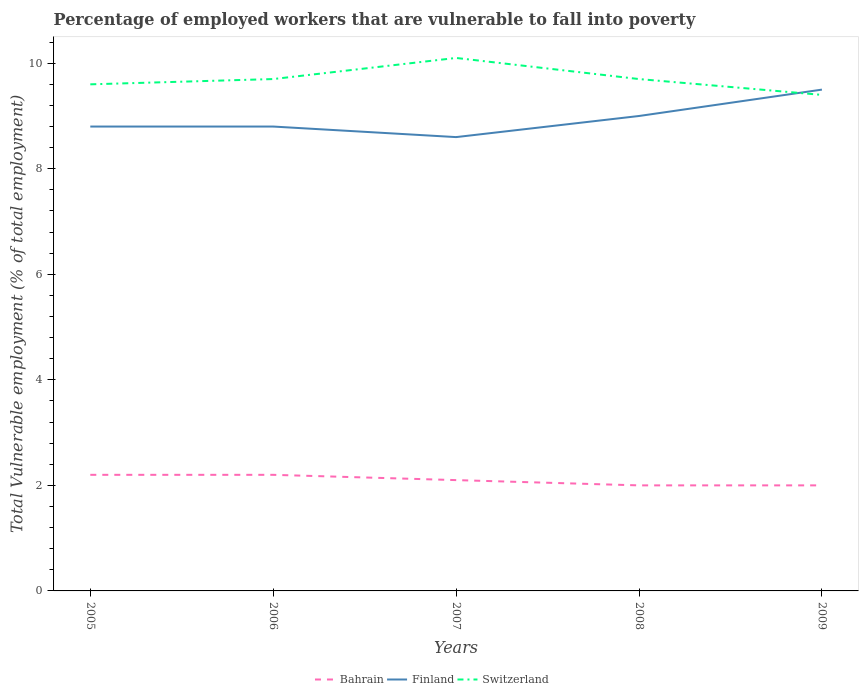Does the line corresponding to Bahrain intersect with the line corresponding to Finland?
Your response must be concise. No. What is the total percentage of employed workers who are vulnerable to fall into poverty in Finland in the graph?
Ensure brevity in your answer.  0. What is the difference between the highest and the second highest percentage of employed workers who are vulnerable to fall into poverty in Finland?
Make the answer very short. 0.9. What is the difference between the highest and the lowest percentage of employed workers who are vulnerable to fall into poverty in Switzerland?
Your answer should be compact. 1. What is the difference between two consecutive major ticks on the Y-axis?
Offer a very short reply. 2. Where does the legend appear in the graph?
Make the answer very short. Bottom center. How are the legend labels stacked?
Keep it short and to the point. Horizontal. What is the title of the graph?
Make the answer very short. Percentage of employed workers that are vulnerable to fall into poverty. What is the label or title of the Y-axis?
Provide a succinct answer. Total Vulnerable employment (% of total employment). What is the Total Vulnerable employment (% of total employment) of Bahrain in 2005?
Provide a short and direct response. 2.2. What is the Total Vulnerable employment (% of total employment) in Finland in 2005?
Your answer should be very brief. 8.8. What is the Total Vulnerable employment (% of total employment) of Switzerland in 2005?
Your answer should be compact. 9.6. What is the Total Vulnerable employment (% of total employment) of Bahrain in 2006?
Make the answer very short. 2.2. What is the Total Vulnerable employment (% of total employment) in Finland in 2006?
Offer a terse response. 8.8. What is the Total Vulnerable employment (% of total employment) in Switzerland in 2006?
Offer a terse response. 9.7. What is the Total Vulnerable employment (% of total employment) of Bahrain in 2007?
Offer a terse response. 2.1. What is the Total Vulnerable employment (% of total employment) in Finland in 2007?
Provide a short and direct response. 8.6. What is the Total Vulnerable employment (% of total employment) in Switzerland in 2007?
Offer a very short reply. 10.1. What is the Total Vulnerable employment (% of total employment) of Switzerland in 2008?
Your response must be concise. 9.7. What is the Total Vulnerable employment (% of total employment) of Bahrain in 2009?
Make the answer very short. 2. What is the Total Vulnerable employment (% of total employment) in Finland in 2009?
Provide a succinct answer. 9.5. What is the Total Vulnerable employment (% of total employment) in Switzerland in 2009?
Give a very brief answer. 9.4. Across all years, what is the maximum Total Vulnerable employment (% of total employment) of Bahrain?
Make the answer very short. 2.2. Across all years, what is the maximum Total Vulnerable employment (% of total employment) in Switzerland?
Ensure brevity in your answer.  10.1. Across all years, what is the minimum Total Vulnerable employment (% of total employment) in Bahrain?
Your answer should be very brief. 2. Across all years, what is the minimum Total Vulnerable employment (% of total employment) in Finland?
Keep it short and to the point. 8.6. Across all years, what is the minimum Total Vulnerable employment (% of total employment) of Switzerland?
Provide a succinct answer. 9.4. What is the total Total Vulnerable employment (% of total employment) of Bahrain in the graph?
Your answer should be very brief. 10.5. What is the total Total Vulnerable employment (% of total employment) of Finland in the graph?
Offer a terse response. 44.7. What is the total Total Vulnerable employment (% of total employment) of Switzerland in the graph?
Provide a succinct answer. 48.5. What is the difference between the Total Vulnerable employment (% of total employment) in Finland in 2005 and that in 2006?
Your answer should be very brief. 0. What is the difference between the Total Vulnerable employment (% of total employment) of Finland in 2005 and that in 2007?
Your response must be concise. 0.2. What is the difference between the Total Vulnerable employment (% of total employment) in Finland in 2005 and that in 2008?
Your answer should be compact. -0.2. What is the difference between the Total Vulnerable employment (% of total employment) of Switzerland in 2005 and that in 2008?
Your answer should be compact. -0.1. What is the difference between the Total Vulnerable employment (% of total employment) of Switzerland in 2005 and that in 2009?
Your response must be concise. 0.2. What is the difference between the Total Vulnerable employment (% of total employment) of Bahrain in 2006 and that in 2008?
Give a very brief answer. 0.2. What is the difference between the Total Vulnerable employment (% of total employment) in Switzerland in 2006 and that in 2008?
Offer a very short reply. 0. What is the difference between the Total Vulnerable employment (% of total employment) of Finland in 2006 and that in 2009?
Give a very brief answer. -0.7. What is the difference between the Total Vulnerable employment (% of total employment) of Bahrain in 2007 and that in 2008?
Provide a succinct answer. 0.1. What is the difference between the Total Vulnerable employment (% of total employment) in Finland in 2007 and that in 2009?
Your answer should be very brief. -0.9. What is the difference between the Total Vulnerable employment (% of total employment) in Finland in 2008 and that in 2009?
Your answer should be compact. -0.5. What is the difference between the Total Vulnerable employment (% of total employment) in Finland in 2005 and the Total Vulnerable employment (% of total employment) in Switzerland in 2006?
Your answer should be very brief. -0.9. What is the difference between the Total Vulnerable employment (% of total employment) in Bahrain in 2005 and the Total Vulnerable employment (% of total employment) in Finland in 2007?
Keep it short and to the point. -6.4. What is the difference between the Total Vulnerable employment (% of total employment) in Bahrain in 2005 and the Total Vulnerable employment (% of total employment) in Switzerland in 2009?
Give a very brief answer. -7.2. What is the difference between the Total Vulnerable employment (% of total employment) in Bahrain in 2006 and the Total Vulnerable employment (% of total employment) in Finland in 2007?
Ensure brevity in your answer.  -6.4. What is the difference between the Total Vulnerable employment (% of total employment) in Finland in 2006 and the Total Vulnerable employment (% of total employment) in Switzerland in 2007?
Your answer should be very brief. -1.3. What is the difference between the Total Vulnerable employment (% of total employment) in Bahrain in 2006 and the Total Vulnerable employment (% of total employment) in Finland in 2008?
Keep it short and to the point. -6.8. What is the difference between the Total Vulnerable employment (% of total employment) in Finland in 2006 and the Total Vulnerable employment (% of total employment) in Switzerland in 2008?
Provide a succinct answer. -0.9. What is the difference between the Total Vulnerable employment (% of total employment) of Bahrain in 2006 and the Total Vulnerable employment (% of total employment) of Finland in 2009?
Keep it short and to the point. -7.3. What is the difference between the Total Vulnerable employment (% of total employment) in Bahrain in 2006 and the Total Vulnerable employment (% of total employment) in Switzerland in 2009?
Your response must be concise. -7.2. What is the difference between the Total Vulnerable employment (% of total employment) in Bahrain in 2007 and the Total Vulnerable employment (% of total employment) in Finland in 2008?
Offer a very short reply. -6.9. What is the difference between the Total Vulnerable employment (% of total employment) of Bahrain in 2007 and the Total Vulnerable employment (% of total employment) of Switzerland in 2008?
Make the answer very short. -7.6. What is the difference between the Total Vulnerable employment (% of total employment) in Finland in 2007 and the Total Vulnerable employment (% of total employment) in Switzerland in 2009?
Keep it short and to the point. -0.8. What is the difference between the Total Vulnerable employment (% of total employment) in Bahrain in 2008 and the Total Vulnerable employment (% of total employment) in Finland in 2009?
Give a very brief answer. -7.5. What is the difference between the Total Vulnerable employment (% of total employment) of Finland in 2008 and the Total Vulnerable employment (% of total employment) of Switzerland in 2009?
Make the answer very short. -0.4. What is the average Total Vulnerable employment (% of total employment) in Bahrain per year?
Provide a short and direct response. 2.1. What is the average Total Vulnerable employment (% of total employment) in Finland per year?
Keep it short and to the point. 8.94. What is the average Total Vulnerable employment (% of total employment) in Switzerland per year?
Your answer should be compact. 9.7. In the year 2005, what is the difference between the Total Vulnerable employment (% of total employment) in Bahrain and Total Vulnerable employment (% of total employment) in Finland?
Make the answer very short. -6.6. In the year 2005, what is the difference between the Total Vulnerable employment (% of total employment) of Finland and Total Vulnerable employment (% of total employment) of Switzerland?
Provide a succinct answer. -0.8. In the year 2006, what is the difference between the Total Vulnerable employment (% of total employment) in Bahrain and Total Vulnerable employment (% of total employment) in Switzerland?
Provide a succinct answer. -7.5. In the year 2006, what is the difference between the Total Vulnerable employment (% of total employment) in Finland and Total Vulnerable employment (% of total employment) in Switzerland?
Offer a very short reply. -0.9. In the year 2007, what is the difference between the Total Vulnerable employment (% of total employment) in Bahrain and Total Vulnerable employment (% of total employment) in Finland?
Your answer should be compact. -6.5. In the year 2007, what is the difference between the Total Vulnerable employment (% of total employment) of Bahrain and Total Vulnerable employment (% of total employment) of Switzerland?
Your response must be concise. -8. In the year 2008, what is the difference between the Total Vulnerable employment (% of total employment) of Bahrain and Total Vulnerable employment (% of total employment) of Finland?
Provide a short and direct response. -7. What is the ratio of the Total Vulnerable employment (% of total employment) in Bahrain in 2005 to that in 2006?
Your response must be concise. 1. What is the ratio of the Total Vulnerable employment (% of total employment) of Switzerland in 2005 to that in 2006?
Keep it short and to the point. 0.99. What is the ratio of the Total Vulnerable employment (% of total employment) in Bahrain in 2005 to that in 2007?
Provide a succinct answer. 1.05. What is the ratio of the Total Vulnerable employment (% of total employment) of Finland in 2005 to that in 2007?
Offer a terse response. 1.02. What is the ratio of the Total Vulnerable employment (% of total employment) of Switzerland in 2005 to that in 2007?
Provide a short and direct response. 0.95. What is the ratio of the Total Vulnerable employment (% of total employment) in Bahrain in 2005 to that in 2008?
Offer a terse response. 1.1. What is the ratio of the Total Vulnerable employment (% of total employment) in Finland in 2005 to that in 2008?
Give a very brief answer. 0.98. What is the ratio of the Total Vulnerable employment (% of total employment) of Bahrain in 2005 to that in 2009?
Offer a very short reply. 1.1. What is the ratio of the Total Vulnerable employment (% of total employment) of Finland in 2005 to that in 2009?
Provide a short and direct response. 0.93. What is the ratio of the Total Vulnerable employment (% of total employment) of Switzerland in 2005 to that in 2009?
Your answer should be compact. 1.02. What is the ratio of the Total Vulnerable employment (% of total employment) in Bahrain in 2006 to that in 2007?
Keep it short and to the point. 1.05. What is the ratio of the Total Vulnerable employment (% of total employment) of Finland in 2006 to that in 2007?
Your answer should be very brief. 1.02. What is the ratio of the Total Vulnerable employment (% of total employment) of Switzerland in 2006 to that in 2007?
Your answer should be very brief. 0.96. What is the ratio of the Total Vulnerable employment (% of total employment) in Finland in 2006 to that in 2008?
Make the answer very short. 0.98. What is the ratio of the Total Vulnerable employment (% of total employment) in Bahrain in 2006 to that in 2009?
Keep it short and to the point. 1.1. What is the ratio of the Total Vulnerable employment (% of total employment) in Finland in 2006 to that in 2009?
Offer a very short reply. 0.93. What is the ratio of the Total Vulnerable employment (% of total employment) in Switzerland in 2006 to that in 2009?
Offer a very short reply. 1.03. What is the ratio of the Total Vulnerable employment (% of total employment) of Finland in 2007 to that in 2008?
Provide a short and direct response. 0.96. What is the ratio of the Total Vulnerable employment (% of total employment) in Switzerland in 2007 to that in 2008?
Your answer should be very brief. 1.04. What is the ratio of the Total Vulnerable employment (% of total employment) of Bahrain in 2007 to that in 2009?
Your response must be concise. 1.05. What is the ratio of the Total Vulnerable employment (% of total employment) in Finland in 2007 to that in 2009?
Provide a succinct answer. 0.91. What is the ratio of the Total Vulnerable employment (% of total employment) of Switzerland in 2007 to that in 2009?
Offer a very short reply. 1.07. What is the ratio of the Total Vulnerable employment (% of total employment) of Bahrain in 2008 to that in 2009?
Your response must be concise. 1. What is the ratio of the Total Vulnerable employment (% of total employment) in Finland in 2008 to that in 2009?
Offer a terse response. 0.95. What is the ratio of the Total Vulnerable employment (% of total employment) in Switzerland in 2008 to that in 2009?
Provide a short and direct response. 1.03. What is the difference between the highest and the second highest Total Vulnerable employment (% of total employment) in Bahrain?
Your answer should be very brief. 0. What is the difference between the highest and the second highest Total Vulnerable employment (% of total employment) of Switzerland?
Your answer should be very brief. 0.4. 